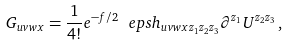Convert formula to latex. <formula><loc_0><loc_0><loc_500><loc_500>G _ { u v w x } = \frac { 1 } { 4 ! } e ^ { - f / 2 } \ e p s h _ { u v w x z _ { 1 } z _ { 2 } z _ { 3 } } \partial ^ { z _ { 1 } } U ^ { z _ { 2 } z _ { 3 } } \, ,</formula> 